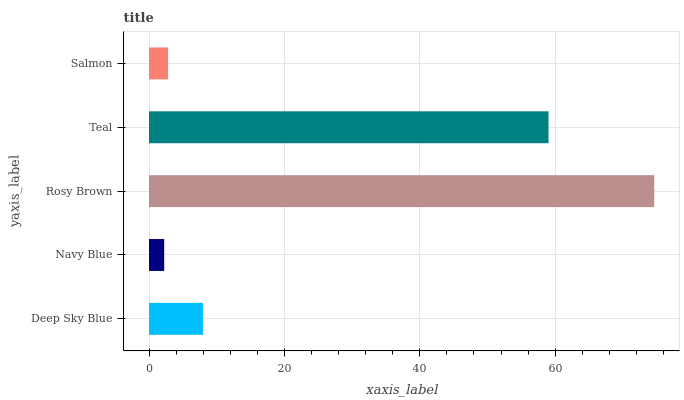Is Navy Blue the minimum?
Answer yes or no. Yes. Is Rosy Brown the maximum?
Answer yes or no. Yes. Is Rosy Brown the minimum?
Answer yes or no. No. Is Navy Blue the maximum?
Answer yes or no. No. Is Rosy Brown greater than Navy Blue?
Answer yes or no. Yes. Is Navy Blue less than Rosy Brown?
Answer yes or no. Yes. Is Navy Blue greater than Rosy Brown?
Answer yes or no. No. Is Rosy Brown less than Navy Blue?
Answer yes or no. No. Is Deep Sky Blue the high median?
Answer yes or no. Yes. Is Deep Sky Blue the low median?
Answer yes or no. Yes. Is Navy Blue the high median?
Answer yes or no. No. Is Navy Blue the low median?
Answer yes or no. No. 